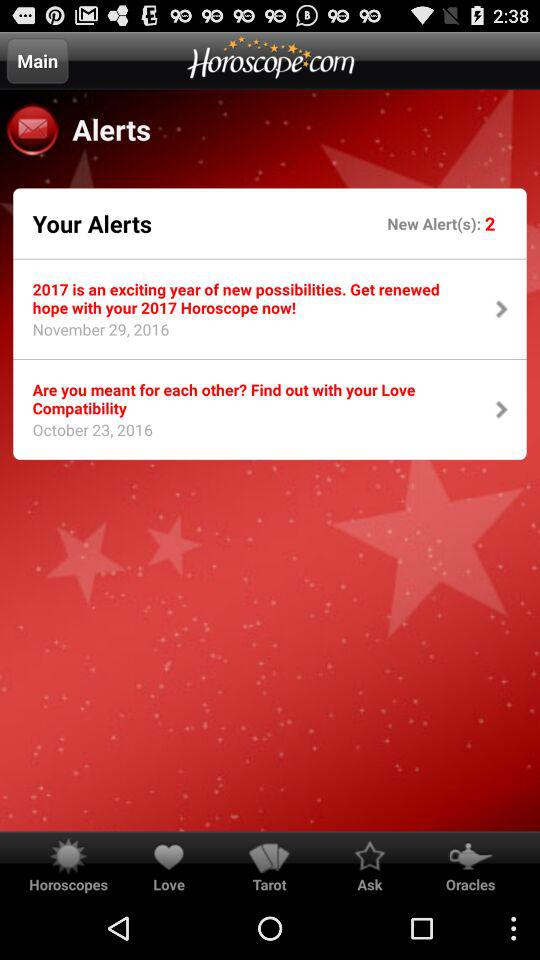How many alerts are there in total?
Answer the question using a single word or phrase. 2 